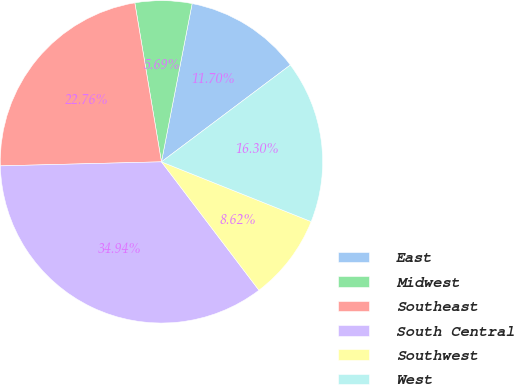Convert chart. <chart><loc_0><loc_0><loc_500><loc_500><pie_chart><fcel>East<fcel>Midwest<fcel>Southeast<fcel>South Central<fcel>Southwest<fcel>West<nl><fcel>11.7%<fcel>5.69%<fcel>22.76%<fcel>34.94%<fcel>8.62%<fcel>16.3%<nl></chart> 